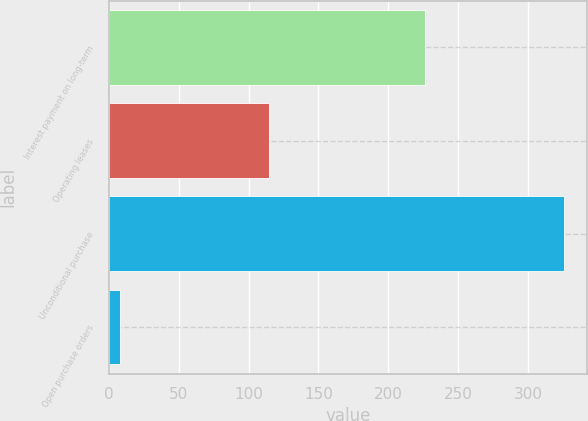<chart> <loc_0><loc_0><loc_500><loc_500><bar_chart><fcel>Interest payment on long-term<fcel>Operating leases<fcel>Unconditional purchase<fcel>Open purchase orders<nl><fcel>226<fcel>115<fcel>326<fcel>8<nl></chart> 